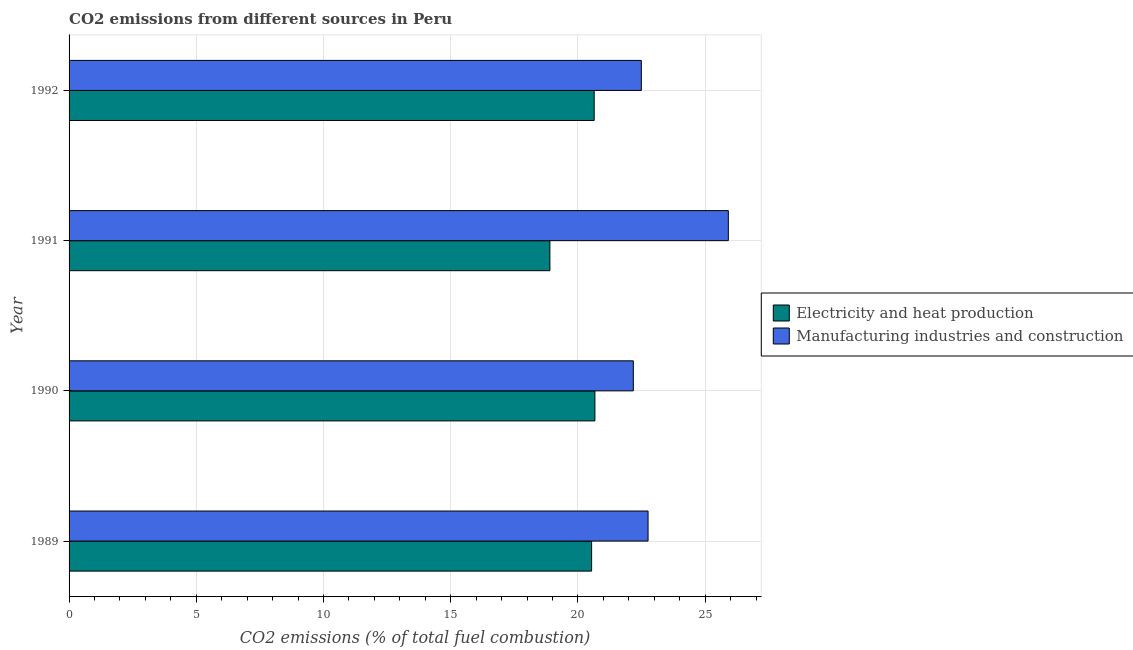Are the number of bars per tick equal to the number of legend labels?
Your answer should be compact. Yes. In how many cases, is the number of bars for a given year not equal to the number of legend labels?
Your answer should be compact. 0. What is the co2 emissions due to manufacturing industries in 1991?
Provide a short and direct response. 25.91. Across all years, what is the maximum co2 emissions due to manufacturing industries?
Your answer should be compact. 25.91. Across all years, what is the minimum co2 emissions due to electricity and heat production?
Your answer should be compact. 18.9. In which year was the co2 emissions due to electricity and heat production maximum?
Offer a terse response. 1990. What is the total co2 emissions due to electricity and heat production in the graph?
Offer a terse response. 80.74. What is the difference between the co2 emissions due to electricity and heat production in 1990 and that in 1991?
Your answer should be compact. 1.77. What is the difference between the co2 emissions due to manufacturing industries in 1990 and the co2 emissions due to electricity and heat production in 1992?
Give a very brief answer. 1.54. What is the average co2 emissions due to electricity and heat production per year?
Give a very brief answer. 20.18. In the year 1990, what is the difference between the co2 emissions due to electricity and heat production and co2 emissions due to manufacturing industries?
Give a very brief answer. -1.51. In how many years, is the co2 emissions due to electricity and heat production greater than 15 %?
Give a very brief answer. 4. What is the ratio of the co2 emissions due to electricity and heat production in 1989 to that in 1992?
Give a very brief answer. 0.99. Is the co2 emissions due to electricity and heat production in 1990 less than that in 1991?
Give a very brief answer. No. What is the difference between the highest and the second highest co2 emissions due to electricity and heat production?
Provide a short and direct response. 0.03. What is the difference between the highest and the lowest co2 emissions due to electricity and heat production?
Your answer should be compact. 1.77. What does the 1st bar from the top in 1990 represents?
Offer a very short reply. Manufacturing industries and construction. What does the 2nd bar from the bottom in 1991 represents?
Ensure brevity in your answer.  Manufacturing industries and construction. How many bars are there?
Offer a terse response. 8. How many years are there in the graph?
Give a very brief answer. 4. What is the difference between two consecutive major ticks on the X-axis?
Keep it short and to the point. 5. Does the graph contain any zero values?
Ensure brevity in your answer.  No. Does the graph contain grids?
Offer a terse response. Yes. Where does the legend appear in the graph?
Provide a succinct answer. Center right. How many legend labels are there?
Offer a very short reply. 2. How are the legend labels stacked?
Give a very brief answer. Vertical. What is the title of the graph?
Ensure brevity in your answer.  CO2 emissions from different sources in Peru. What is the label or title of the X-axis?
Your answer should be compact. CO2 emissions (% of total fuel combustion). What is the CO2 emissions (% of total fuel combustion) of Electricity and heat production in 1989?
Keep it short and to the point. 20.54. What is the CO2 emissions (% of total fuel combustion) in Manufacturing industries and construction in 1989?
Your response must be concise. 22.76. What is the CO2 emissions (% of total fuel combustion) in Electricity and heat production in 1990?
Make the answer very short. 20.67. What is the CO2 emissions (% of total fuel combustion) in Manufacturing industries and construction in 1990?
Offer a terse response. 22.18. What is the CO2 emissions (% of total fuel combustion) of Electricity and heat production in 1991?
Offer a terse response. 18.9. What is the CO2 emissions (% of total fuel combustion) in Manufacturing industries and construction in 1991?
Your response must be concise. 25.91. What is the CO2 emissions (% of total fuel combustion) in Electricity and heat production in 1992?
Give a very brief answer. 20.64. What is the CO2 emissions (% of total fuel combustion) of Manufacturing industries and construction in 1992?
Offer a very short reply. 22.49. Across all years, what is the maximum CO2 emissions (% of total fuel combustion) of Electricity and heat production?
Keep it short and to the point. 20.67. Across all years, what is the maximum CO2 emissions (% of total fuel combustion) of Manufacturing industries and construction?
Your response must be concise. 25.91. Across all years, what is the minimum CO2 emissions (% of total fuel combustion) of Electricity and heat production?
Make the answer very short. 18.9. Across all years, what is the minimum CO2 emissions (% of total fuel combustion) of Manufacturing industries and construction?
Make the answer very short. 22.18. What is the total CO2 emissions (% of total fuel combustion) of Electricity and heat production in the graph?
Your answer should be compact. 80.74. What is the total CO2 emissions (% of total fuel combustion) of Manufacturing industries and construction in the graph?
Offer a terse response. 93.33. What is the difference between the CO2 emissions (% of total fuel combustion) of Electricity and heat production in 1989 and that in 1990?
Your answer should be very brief. -0.13. What is the difference between the CO2 emissions (% of total fuel combustion) of Manufacturing industries and construction in 1989 and that in 1990?
Offer a very short reply. 0.58. What is the difference between the CO2 emissions (% of total fuel combustion) in Electricity and heat production in 1989 and that in 1991?
Keep it short and to the point. 1.64. What is the difference between the CO2 emissions (% of total fuel combustion) of Manufacturing industries and construction in 1989 and that in 1991?
Your response must be concise. -3.15. What is the difference between the CO2 emissions (% of total fuel combustion) of Electricity and heat production in 1989 and that in 1992?
Keep it short and to the point. -0.1. What is the difference between the CO2 emissions (% of total fuel combustion) in Manufacturing industries and construction in 1989 and that in 1992?
Your answer should be very brief. 0.26. What is the difference between the CO2 emissions (% of total fuel combustion) of Electricity and heat production in 1990 and that in 1991?
Your answer should be very brief. 1.77. What is the difference between the CO2 emissions (% of total fuel combustion) of Manufacturing industries and construction in 1990 and that in 1991?
Your answer should be compact. -3.73. What is the difference between the CO2 emissions (% of total fuel combustion) of Electricity and heat production in 1990 and that in 1992?
Make the answer very short. 0.03. What is the difference between the CO2 emissions (% of total fuel combustion) of Manufacturing industries and construction in 1990 and that in 1992?
Your answer should be compact. -0.32. What is the difference between the CO2 emissions (% of total fuel combustion) of Electricity and heat production in 1991 and that in 1992?
Give a very brief answer. -1.74. What is the difference between the CO2 emissions (% of total fuel combustion) of Manufacturing industries and construction in 1991 and that in 1992?
Ensure brevity in your answer.  3.42. What is the difference between the CO2 emissions (% of total fuel combustion) of Electricity and heat production in 1989 and the CO2 emissions (% of total fuel combustion) of Manufacturing industries and construction in 1990?
Ensure brevity in your answer.  -1.64. What is the difference between the CO2 emissions (% of total fuel combustion) in Electricity and heat production in 1989 and the CO2 emissions (% of total fuel combustion) in Manufacturing industries and construction in 1991?
Your answer should be compact. -5.37. What is the difference between the CO2 emissions (% of total fuel combustion) of Electricity and heat production in 1989 and the CO2 emissions (% of total fuel combustion) of Manufacturing industries and construction in 1992?
Your answer should be very brief. -1.95. What is the difference between the CO2 emissions (% of total fuel combustion) in Electricity and heat production in 1990 and the CO2 emissions (% of total fuel combustion) in Manufacturing industries and construction in 1991?
Your answer should be very brief. -5.24. What is the difference between the CO2 emissions (% of total fuel combustion) in Electricity and heat production in 1990 and the CO2 emissions (% of total fuel combustion) in Manufacturing industries and construction in 1992?
Your answer should be very brief. -1.82. What is the difference between the CO2 emissions (% of total fuel combustion) in Electricity and heat production in 1991 and the CO2 emissions (% of total fuel combustion) in Manufacturing industries and construction in 1992?
Offer a terse response. -3.59. What is the average CO2 emissions (% of total fuel combustion) of Electricity and heat production per year?
Make the answer very short. 20.18. What is the average CO2 emissions (% of total fuel combustion) of Manufacturing industries and construction per year?
Provide a short and direct response. 23.33. In the year 1989, what is the difference between the CO2 emissions (% of total fuel combustion) of Electricity and heat production and CO2 emissions (% of total fuel combustion) of Manufacturing industries and construction?
Keep it short and to the point. -2.22. In the year 1990, what is the difference between the CO2 emissions (% of total fuel combustion) of Electricity and heat production and CO2 emissions (% of total fuel combustion) of Manufacturing industries and construction?
Make the answer very short. -1.51. In the year 1991, what is the difference between the CO2 emissions (% of total fuel combustion) in Electricity and heat production and CO2 emissions (% of total fuel combustion) in Manufacturing industries and construction?
Provide a succinct answer. -7.01. In the year 1992, what is the difference between the CO2 emissions (% of total fuel combustion) of Electricity and heat production and CO2 emissions (% of total fuel combustion) of Manufacturing industries and construction?
Ensure brevity in your answer.  -1.85. What is the ratio of the CO2 emissions (% of total fuel combustion) in Electricity and heat production in 1989 to that in 1990?
Your answer should be compact. 0.99. What is the ratio of the CO2 emissions (% of total fuel combustion) of Manufacturing industries and construction in 1989 to that in 1990?
Offer a terse response. 1.03. What is the ratio of the CO2 emissions (% of total fuel combustion) of Electricity and heat production in 1989 to that in 1991?
Your answer should be very brief. 1.09. What is the ratio of the CO2 emissions (% of total fuel combustion) of Manufacturing industries and construction in 1989 to that in 1991?
Provide a short and direct response. 0.88. What is the ratio of the CO2 emissions (% of total fuel combustion) of Manufacturing industries and construction in 1989 to that in 1992?
Offer a very short reply. 1.01. What is the ratio of the CO2 emissions (% of total fuel combustion) in Electricity and heat production in 1990 to that in 1991?
Your answer should be very brief. 1.09. What is the ratio of the CO2 emissions (% of total fuel combustion) of Manufacturing industries and construction in 1990 to that in 1991?
Your response must be concise. 0.86. What is the ratio of the CO2 emissions (% of total fuel combustion) in Electricity and heat production in 1990 to that in 1992?
Provide a short and direct response. 1. What is the ratio of the CO2 emissions (% of total fuel combustion) in Manufacturing industries and construction in 1990 to that in 1992?
Keep it short and to the point. 0.99. What is the ratio of the CO2 emissions (% of total fuel combustion) of Electricity and heat production in 1991 to that in 1992?
Your answer should be very brief. 0.92. What is the ratio of the CO2 emissions (% of total fuel combustion) of Manufacturing industries and construction in 1991 to that in 1992?
Your answer should be compact. 1.15. What is the difference between the highest and the second highest CO2 emissions (% of total fuel combustion) of Electricity and heat production?
Ensure brevity in your answer.  0.03. What is the difference between the highest and the second highest CO2 emissions (% of total fuel combustion) of Manufacturing industries and construction?
Provide a succinct answer. 3.15. What is the difference between the highest and the lowest CO2 emissions (% of total fuel combustion) in Electricity and heat production?
Your answer should be very brief. 1.77. What is the difference between the highest and the lowest CO2 emissions (% of total fuel combustion) of Manufacturing industries and construction?
Your answer should be compact. 3.73. 